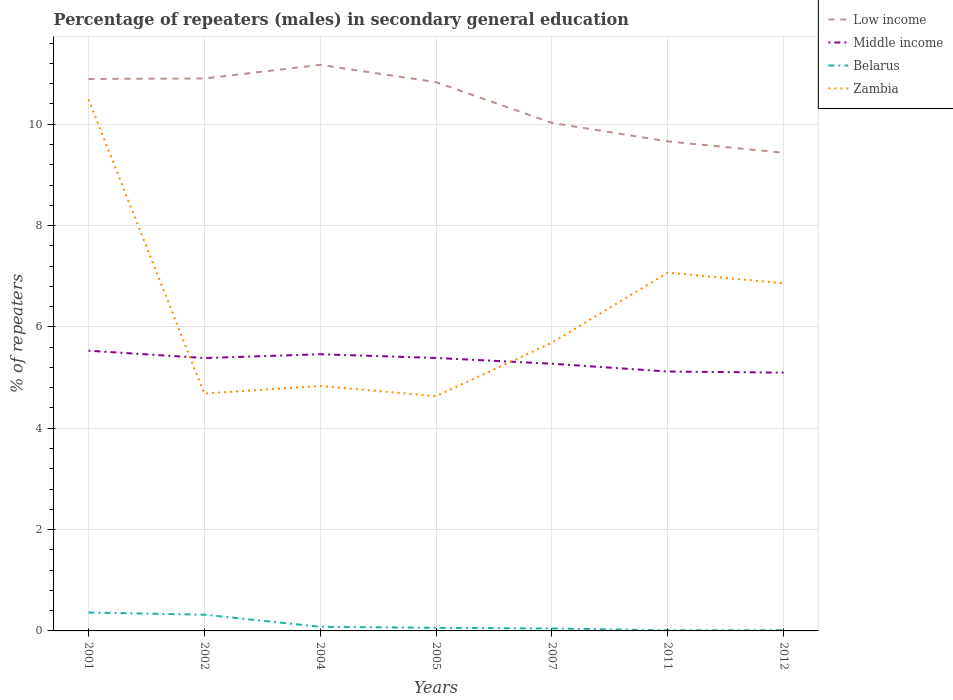How many different coloured lines are there?
Your answer should be very brief. 4. Across all years, what is the maximum percentage of male repeaters in Belarus?
Provide a succinct answer. 0.01. What is the total percentage of male repeaters in Belarus in the graph?
Your answer should be very brief. 0.28. What is the difference between the highest and the second highest percentage of male repeaters in Belarus?
Offer a very short reply. 0.35. What is the difference between the highest and the lowest percentage of male repeaters in Middle income?
Your response must be concise. 4. Is the percentage of male repeaters in Middle income strictly greater than the percentage of male repeaters in Zambia over the years?
Ensure brevity in your answer.  No. How many lines are there?
Ensure brevity in your answer.  4. How many years are there in the graph?
Your response must be concise. 7. What is the difference between two consecutive major ticks on the Y-axis?
Provide a short and direct response. 2. Are the values on the major ticks of Y-axis written in scientific E-notation?
Your response must be concise. No. Does the graph contain any zero values?
Your response must be concise. No. Does the graph contain grids?
Ensure brevity in your answer.  Yes. How are the legend labels stacked?
Provide a succinct answer. Vertical. What is the title of the graph?
Offer a very short reply. Percentage of repeaters (males) in secondary general education. What is the label or title of the Y-axis?
Your answer should be very brief. % of repeaters. What is the % of repeaters of Low income in 2001?
Provide a short and direct response. 10.89. What is the % of repeaters in Middle income in 2001?
Offer a terse response. 5.53. What is the % of repeaters of Belarus in 2001?
Provide a short and direct response. 0.36. What is the % of repeaters in Zambia in 2001?
Provide a succinct answer. 10.49. What is the % of repeaters of Low income in 2002?
Provide a short and direct response. 10.9. What is the % of repeaters of Middle income in 2002?
Provide a short and direct response. 5.39. What is the % of repeaters in Belarus in 2002?
Give a very brief answer. 0.32. What is the % of repeaters of Zambia in 2002?
Provide a succinct answer. 4.68. What is the % of repeaters of Low income in 2004?
Offer a very short reply. 11.17. What is the % of repeaters in Middle income in 2004?
Ensure brevity in your answer.  5.46. What is the % of repeaters of Belarus in 2004?
Give a very brief answer. 0.08. What is the % of repeaters in Zambia in 2004?
Provide a short and direct response. 4.83. What is the % of repeaters of Low income in 2005?
Your response must be concise. 10.83. What is the % of repeaters of Middle income in 2005?
Provide a succinct answer. 5.39. What is the % of repeaters of Belarus in 2005?
Offer a very short reply. 0.06. What is the % of repeaters in Zambia in 2005?
Your answer should be very brief. 4.63. What is the % of repeaters in Low income in 2007?
Give a very brief answer. 10.03. What is the % of repeaters in Middle income in 2007?
Give a very brief answer. 5.27. What is the % of repeaters of Belarus in 2007?
Give a very brief answer. 0.05. What is the % of repeaters of Zambia in 2007?
Your answer should be compact. 5.69. What is the % of repeaters of Low income in 2011?
Give a very brief answer. 9.66. What is the % of repeaters of Middle income in 2011?
Offer a terse response. 5.12. What is the % of repeaters in Belarus in 2011?
Keep it short and to the point. 0.01. What is the % of repeaters of Zambia in 2011?
Your answer should be compact. 7.07. What is the % of repeaters of Low income in 2012?
Provide a succinct answer. 9.44. What is the % of repeaters of Middle income in 2012?
Provide a succinct answer. 5.1. What is the % of repeaters in Belarus in 2012?
Provide a succinct answer. 0.01. What is the % of repeaters of Zambia in 2012?
Your answer should be compact. 6.86. Across all years, what is the maximum % of repeaters in Low income?
Your response must be concise. 11.17. Across all years, what is the maximum % of repeaters in Middle income?
Ensure brevity in your answer.  5.53. Across all years, what is the maximum % of repeaters in Belarus?
Offer a very short reply. 0.36. Across all years, what is the maximum % of repeaters of Zambia?
Make the answer very short. 10.49. Across all years, what is the minimum % of repeaters of Low income?
Provide a short and direct response. 9.44. Across all years, what is the minimum % of repeaters of Middle income?
Provide a succinct answer. 5.1. Across all years, what is the minimum % of repeaters in Belarus?
Keep it short and to the point. 0.01. Across all years, what is the minimum % of repeaters in Zambia?
Give a very brief answer. 4.63. What is the total % of repeaters in Low income in the graph?
Offer a terse response. 72.92. What is the total % of repeaters in Middle income in the graph?
Provide a succinct answer. 37.25. What is the total % of repeaters in Belarus in the graph?
Provide a succinct answer. 0.9. What is the total % of repeaters in Zambia in the graph?
Your answer should be very brief. 44.26. What is the difference between the % of repeaters in Low income in 2001 and that in 2002?
Your response must be concise. -0.01. What is the difference between the % of repeaters of Middle income in 2001 and that in 2002?
Keep it short and to the point. 0.15. What is the difference between the % of repeaters in Belarus in 2001 and that in 2002?
Ensure brevity in your answer.  0.04. What is the difference between the % of repeaters of Zambia in 2001 and that in 2002?
Your answer should be very brief. 5.81. What is the difference between the % of repeaters of Low income in 2001 and that in 2004?
Make the answer very short. -0.28. What is the difference between the % of repeaters in Middle income in 2001 and that in 2004?
Provide a succinct answer. 0.07. What is the difference between the % of repeaters in Belarus in 2001 and that in 2004?
Provide a short and direct response. 0.28. What is the difference between the % of repeaters of Zambia in 2001 and that in 2004?
Give a very brief answer. 5.66. What is the difference between the % of repeaters of Low income in 2001 and that in 2005?
Your answer should be compact. 0.06. What is the difference between the % of repeaters of Middle income in 2001 and that in 2005?
Ensure brevity in your answer.  0.14. What is the difference between the % of repeaters of Belarus in 2001 and that in 2005?
Keep it short and to the point. 0.3. What is the difference between the % of repeaters in Zambia in 2001 and that in 2005?
Make the answer very short. 5.86. What is the difference between the % of repeaters of Low income in 2001 and that in 2007?
Your answer should be very brief. 0.87. What is the difference between the % of repeaters in Middle income in 2001 and that in 2007?
Your answer should be compact. 0.26. What is the difference between the % of repeaters of Belarus in 2001 and that in 2007?
Give a very brief answer. 0.31. What is the difference between the % of repeaters of Zambia in 2001 and that in 2007?
Your answer should be compact. 4.8. What is the difference between the % of repeaters in Low income in 2001 and that in 2011?
Your response must be concise. 1.23. What is the difference between the % of repeaters of Middle income in 2001 and that in 2011?
Offer a very short reply. 0.41. What is the difference between the % of repeaters of Belarus in 2001 and that in 2011?
Provide a succinct answer. 0.35. What is the difference between the % of repeaters in Zambia in 2001 and that in 2011?
Your answer should be compact. 3.42. What is the difference between the % of repeaters of Low income in 2001 and that in 2012?
Ensure brevity in your answer.  1.46. What is the difference between the % of repeaters of Middle income in 2001 and that in 2012?
Make the answer very short. 0.43. What is the difference between the % of repeaters of Belarus in 2001 and that in 2012?
Offer a very short reply. 0.35. What is the difference between the % of repeaters of Zambia in 2001 and that in 2012?
Offer a very short reply. 3.63. What is the difference between the % of repeaters in Low income in 2002 and that in 2004?
Provide a succinct answer. -0.27. What is the difference between the % of repeaters in Middle income in 2002 and that in 2004?
Make the answer very short. -0.07. What is the difference between the % of repeaters of Belarus in 2002 and that in 2004?
Make the answer very short. 0.24. What is the difference between the % of repeaters in Zambia in 2002 and that in 2004?
Your response must be concise. -0.15. What is the difference between the % of repeaters of Low income in 2002 and that in 2005?
Keep it short and to the point. 0.07. What is the difference between the % of repeaters of Middle income in 2002 and that in 2005?
Ensure brevity in your answer.  -0. What is the difference between the % of repeaters of Belarus in 2002 and that in 2005?
Keep it short and to the point. 0.26. What is the difference between the % of repeaters in Zambia in 2002 and that in 2005?
Offer a terse response. 0.05. What is the difference between the % of repeaters of Low income in 2002 and that in 2007?
Offer a very short reply. 0.88. What is the difference between the % of repeaters in Middle income in 2002 and that in 2007?
Ensure brevity in your answer.  0.11. What is the difference between the % of repeaters in Belarus in 2002 and that in 2007?
Give a very brief answer. 0.27. What is the difference between the % of repeaters of Zambia in 2002 and that in 2007?
Ensure brevity in your answer.  -1. What is the difference between the % of repeaters of Low income in 2002 and that in 2011?
Provide a succinct answer. 1.24. What is the difference between the % of repeaters in Middle income in 2002 and that in 2011?
Your answer should be compact. 0.27. What is the difference between the % of repeaters in Belarus in 2002 and that in 2011?
Offer a terse response. 0.31. What is the difference between the % of repeaters of Zambia in 2002 and that in 2011?
Your response must be concise. -2.39. What is the difference between the % of repeaters in Low income in 2002 and that in 2012?
Ensure brevity in your answer.  1.47. What is the difference between the % of repeaters of Middle income in 2002 and that in 2012?
Keep it short and to the point. 0.29. What is the difference between the % of repeaters of Belarus in 2002 and that in 2012?
Keep it short and to the point. 0.31. What is the difference between the % of repeaters of Zambia in 2002 and that in 2012?
Your answer should be very brief. -2.18. What is the difference between the % of repeaters of Low income in 2004 and that in 2005?
Offer a very short reply. 0.34. What is the difference between the % of repeaters of Middle income in 2004 and that in 2005?
Provide a short and direct response. 0.07. What is the difference between the % of repeaters of Belarus in 2004 and that in 2005?
Keep it short and to the point. 0.02. What is the difference between the % of repeaters in Zambia in 2004 and that in 2005?
Offer a very short reply. 0.2. What is the difference between the % of repeaters of Low income in 2004 and that in 2007?
Keep it short and to the point. 1.15. What is the difference between the % of repeaters of Middle income in 2004 and that in 2007?
Your answer should be compact. 0.19. What is the difference between the % of repeaters in Belarus in 2004 and that in 2007?
Ensure brevity in your answer.  0.03. What is the difference between the % of repeaters in Zambia in 2004 and that in 2007?
Your answer should be very brief. -0.85. What is the difference between the % of repeaters in Low income in 2004 and that in 2011?
Your response must be concise. 1.51. What is the difference between the % of repeaters of Middle income in 2004 and that in 2011?
Offer a very short reply. 0.34. What is the difference between the % of repeaters of Belarus in 2004 and that in 2011?
Make the answer very short. 0.07. What is the difference between the % of repeaters in Zambia in 2004 and that in 2011?
Your response must be concise. -2.24. What is the difference between the % of repeaters of Low income in 2004 and that in 2012?
Offer a terse response. 1.74. What is the difference between the % of repeaters in Middle income in 2004 and that in 2012?
Provide a succinct answer. 0.36. What is the difference between the % of repeaters of Belarus in 2004 and that in 2012?
Keep it short and to the point. 0.07. What is the difference between the % of repeaters of Zambia in 2004 and that in 2012?
Your answer should be very brief. -2.03. What is the difference between the % of repeaters in Low income in 2005 and that in 2007?
Your answer should be very brief. 0.8. What is the difference between the % of repeaters in Middle income in 2005 and that in 2007?
Keep it short and to the point. 0.11. What is the difference between the % of repeaters in Belarus in 2005 and that in 2007?
Keep it short and to the point. 0.01. What is the difference between the % of repeaters of Zambia in 2005 and that in 2007?
Offer a terse response. -1.06. What is the difference between the % of repeaters of Low income in 2005 and that in 2011?
Ensure brevity in your answer.  1.17. What is the difference between the % of repeaters of Middle income in 2005 and that in 2011?
Provide a succinct answer. 0.27. What is the difference between the % of repeaters of Belarus in 2005 and that in 2011?
Keep it short and to the point. 0.05. What is the difference between the % of repeaters of Zambia in 2005 and that in 2011?
Your answer should be compact. -2.44. What is the difference between the % of repeaters of Low income in 2005 and that in 2012?
Your response must be concise. 1.39. What is the difference between the % of repeaters of Middle income in 2005 and that in 2012?
Provide a succinct answer. 0.29. What is the difference between the % of repeaters in Belarus in 2005 and that in 2012?
Your answer should be compact. 0.05. What is the difference between the % of repeaters of Zambia in 2005 and that in 2012?
Keep it short and to the point. -2.23. What is the difference between the % of repeaters of Low income in 2007 and that in 2011?
Provide a short and direct response. 0.36. What is the difference between the % of repeaters in Middle income in 2007 and that in 2011?
Make the answer very short. 0.15. What is the difference between the % of repeaters of Belarus in 2007 and that in 2011?
Give a very brief answer. 0.04. What is the difference between the % of repeaters in Zambia in 2007 and that in 2011?
Provide a succinct answer. -1.38. What is the difference between the % of repeaters of Low income in 2007 and that in 2012?
Your response must be concise. 0.59. What is the difference between the % of repeaters of Middle income in 2007 and that in 2012?
Make the answer very short. 0.18. What is the difference between the % of repeaters in Belarus in 2007 and that in 2012?
Keep it short and to the point. 0.04. What is the difference between the % of repeaters of Zambia in 2007 and that in 2012?
Make the answer very short. -1.17. What is the difference between the % of repeaters of Low income in 2011 and that in 2012?
Your response must be concise. 0.22. What is the difference between the % of repeaters of Middle income in 2011 and that in 2012?
Provide a succinct answer. 0.02. What is the difference between the % of repeaters in Belarus in 2011 and that in 2012?
Offer a terse response. -0. What is the difference between the % of repeaters in Zambia in 2011 and that in 2012?
Provide a succinct answer. 0.21. What is the difference between the % of repeaters of Low income in 2001 and the % of repeaters of Middle income in 2002?
Make the answer very short. 5.51. What is the difference between the % of repeaters in Low income in 2001 and the % of repeaters in Belarus in 2002?
Your response must be concise. 10.57. What is the difference between the % of repeaters of Low income in 2001 and the % of repeaters of Zambia in 2002?
Keep it short and to the point. 6.21. What is the difference between the % of repeaters of Middle income in 2001 and the % of repeaters of Belarus in 2002?
Your answer should be very brief. 5.21. What is the difference between the % of repeaters in Middle income in 2001 and the % of repeaters in Zambia in 2002?
Make the answer very short. 0.85. What is the difference between the % of repeaters in Belarus in 2001 and the % of repeaters in Zambia in 2002?
Your answer should be compact. -4.32. What is the difference between the % of repeaters in Low income in 2001 and the % of repeaters in Middle income in 2004?
Your response must be concise. 5.43. What is the difference between the % of repeaters of Low income in 2001 and the % of repeaters of Belarus in 2004?
Ensure brevity in your answer.  10.81. What is the difference between the % of repeaters of Low income in 2001 and the % of repeaters of Zambia in 2004?
Keep it short and to the point. 6.06. What is the difference between the % of repeaters of Middle income in 2001 and the % of repeaters of Belarus in 2004?
Offer a terse response. 5.45. What is the difference between the % of repeaters in Middle income in 2001 and the % of repeaters in Zambia in 2004?
Your answer should be compact. 0.7. What is the difference between the % of repeaters in Belarus in 2001 and the % of repeaters in Zambia in 2004?
Your answer should be compact. -4.47. What is the difference between the % of repeaters of Low income in 2001 and the % of repeaters of Middle income in 2005?
Give a very brief answer. 5.51. What is the difference between the % of repeaters of Low income in 2001 and the % of repeaters of Belarus in 2005?
Ensure brevity in your answer.  10.83. What is the difference between the % of repeaters in Low income in 2001 and the % of repeaters in Zambia in 2005?
Offer a terse response. 6.26. What is the difference between the % of repeaters in Middle income in 2001 and the % of repeaters in Belarus in 2005?
Offer a very short reply. 5.47. What is the difference between the % of repeaters of Middle income in 2001 and the % of repeaters of Zambia in 2005?
Your response must be concise. 0.9. What is the difference between the % of repeaters in Belarus in 2001 and the % of repeaters in Zambia in 2005?
Ensure brevity in your answer.  -4.27. What is the difference between the % of repeaters in Low income in 2001 and the % of repeaters in Middle income in 2007?
Your response must be concise. 5.62. What is the difference between the % of repeaters of Low income in 2001 and the % of repeaters of Belarus in 2007?
Offer a terse response. 10.84. What is the difference between the % of repeaters of Low income in 2001 and the % of repeaters of Zambia in 2007?
Your answer should be compact. 5.2. What is the difference between the % of repeaters of Middle income in 2001 and the % of repeaters of Belarus in 2007?
Keep it short and to the point. 5.48. What is the difference between the % of repeaters in Middle income in 2001 and the % of repeaters in Zambia in 2007?
Make the answer very short. -0.16. What is the difference between the % of repeaters of Belarus in 2001 and the % of repeaters of Zambia in 2007?
Provide a short and direct response. -5.33. What is the difference between the % of repeaters of Low income in 2001 and the % of repeaters of Middle income in 2011?
Offer a terse response. 5.77. What is the difference between the % of repeaters of Low income in 2001 and the % of repeaters of Belarus in 2011?
Your answer should be very brief. 10.88. What is the difference between the % of repeaters of Low income in 2001 and the % of repeaters of Zambia in 2011?
Offer a very short reply. 3.82. What is the difference between the % of repeaters of Middle income in 2001 and the % of repeaters of Belarus in 2011?
Offer a very short reply. 5.52. What is the difference between the % of repeaters in Middle income in 2001 and the % of repeaters in Zambia in 2011?
Provide a succinct answer. -1.54. What is the difference between the % of repeaters of Belarus in 2001 and the % of repeaters of Zambia in 2011?
Make the answer very short. -6.71. What is the difference between the % of repeaters of Low income in 2001 and the % of repeaters of Middle income in 2012?
Provide a short and direct response. 5.8. What is the difference between the % of repeaters in Low income in 2001 and the % of repeaters in Belarus in 2012?
Keep it short and to the point. 10.88. What is the difference between the % of repeaters of Low income in 2001 and the % of repeaters of Zambia in 2012?
Keep it short and to the point. 4.03. What is the difference between the % of repeaters in Middle income in 2001 and the % of repeaters in Belarus in 2012?
Provide a short and direct response. 5.52. What is the difference between the % of repeaters in Middle income in 2001 and the % of repeaters in Zambia in 2012?
Keep it short and to the point. -1.33. What is the difference between the % of repeaters in Belarus in 2001 and the % of repeaters in Zambia in 2012?
Provide a succinct answer. -6.5. What is the difference between the % of repeaters of Low income in 2002 and the % of repeaters of Middle income in 2004?
Make the answer very short. 5.44. What is the difference between the % of repeaters of Low income in 2002 and the % of repeaters of Belarus in 2004?
Keep it short and to the point. 10.82. What is the difference between the % of repeaters in Low income in 2002 and the % of repeaters in Zambia in 2004?
Ensure brevity in your answer.  6.07. What is the difference between the % of repeaters of Middle income in 2002 and the % of repeaters of Belarus in 2004?
Provide a short and direct response. 5.3. What is the difference between the % of repeaters of Middle income in 2002 and the % of repeaters of Zambia in 2004?
Your response must be concise. 0.55. What is the difference between the % of repeaters in Belarus in 2002 and the % of repeaters in Zambia in 2004?
Your answer should be compact. -4.51. What is the difference between the % of repeaters in Low income in 2002 and the % of repeaters in Middle income in 2005?
Provide a succinct answer. 5.52. What is the difference between the % of repeaters of Low income in 2002 and the % of repeaters of Belarus in 2005?
Your answer should be very brief. 10.84. What is the difference between the % of repeaters in Low income in 2002 and the % of repeaters in Zambia in 2005?
Your response must be concise. 6.27. What is the difference between the % of repeaters in Middle income in 2002 and the % of repeaters in Belarus in 2005?
Give a very brief answer. 5.32. What is the difference between the % of repeaters in Middle income in 2002 and the % of repeaters in Zambia in 2005?
Give a very brief answer. 0.75. What is the difference between the % of repeaters of Belarus in 2002 and the % of repeaters of Zambia in 2005?
Offer a very short reply. -4.31. What is the difference between the % of repeaters in Low income in 2002 and the % of repeaters in Middle income in 2007?
Your answer should be very brief. 5.63. What is the difference between the % of repeaters in Low income in 2002 and the % of repeaters in Belarus in 2007?
Keep it short and to the point. 10.85. What is the difference between the % of repeaters in Low income in 2002 and the % of repeaters in Zambia in 2007?
Offer a very short reply. 5.21. What is the difference between the % of repeaters of Middle income in 2002 and the % of repeaters of Belarus in 2007?
Your answer should be compact. 5.34. What is the difference between the % of repeaters of Middle income in 2002 and the % of repeaters of Zambia in 2007?
Offer a terse response. -0.3. What is the difference between the % of repeaters in Belarus in 2002 and the % of repeaters in Zambia in 2007?
Provide a succinct answer. -5.37. What is the difference between the % of repeaters in Low income in 2002 and the % of repeaters in Middle income in 2011?
Keep it short and to the point. 5.78. What is the difference between the % of repeaters in Low income in 2002 and the % of repeaters in Belarus in 2011?
Make the answer very short. 10.89. What is the difference between the % of repeaters of Low income in 2002 and the % of repeaters of Zambia in 2011?
Provide a short and direct response. 3.83. What is the difference between the % of repeaters in Middle income in 2002 and the % of repeaters in Belarus in 2011?
Your answer should be very brief. 5.37. What is the difference between the % of repeaters in Middle income in 2002 and the % of repeaters in Zambia in 2011?
Give a very brief answer. -1.69. What is the difference between the % of repeaters in Belarus in 2002 and the % of repeaters in Zambia in 2011?
Provide a short and direct response. -6.75. What is the difference between the % of repeaters of Low income in 2002 and the % of repeaters of Middle income in 2012?
Make the answer very short. 5.81. What is the difference between the % of repeaters in Low income in 2002 and the % of repeaters in Belarus in 2012?
Provide a succinct answer. 10.89. What is the difference between the % of repeaters in Low income in 2002 and the % of repeaters in Zambia in 2012?
Offer a very short reply. 4.04. What is the difference between the % of repeaters of Middle income in 2002 and the % of repeaters of Belarus in 2012?
Make the answer very short. 5.37. What is the difference between the % of repeaters in Middle income in 2002 and the % of repeaters in Zambia in 2012?
Provide a succinct answer. -1.48. What is the difference between the % of repeaters in Belarus in 2002 and the % of repeaters in Zambia in 2012?
Make the answer very short. -6.54. What is the difference between the % of repeaters in Low income in 2004 and the % of repeaters in Middle income in 2005?
Your response must be concise. 5.78. What is the difference between the % of repeaters in Low income in 2004 and the % of repeaters in Belarus in 2005?
Provide a succinct answer. 11.11. What is the difference between the % of repeaters in Low income in 2004 and the % of repeaters in Zambia in 2005?
Your response must be concise. 6.54. What is the difference between the % of repeaters of Middle income in 2004 and the % of repeaters of Belarus in 2005?
Your response must be concise. 5.4. What is the difference between the % of repeaters in Middle income in 2004 and the % of repeaters in Zambia in 2005?
Your answer should be very brief. 0.83. What is the difference between the % of repeaters of Belarus in 2004 and the % of repeaters of Zambia in 2005?
Ensure brevity in your answer.  -4.55. What is the difference between the % of repeaters of Low income in 2004 and the % of repeaters of Middle income in 2007?
Give a very brief answer. 5.9. What is the difference between the % of repeaters of Low income in 2004 and the % of repeaters of Belarus in 2007?
Provide a short and direct response. 11.12. What is the difference between the % of repeaters of Low income in 2004 and the % of repeaters of Zambia in 2007?
Keep it short and to the point. 5.48. What is the difference between the % of repeaters of Middle income in 2004 and the % of repeaters of Belarus in 2007?
Make the answer very short. 5.41. What is the difference between the % of repeaters in Middle income in 2004 and the % of repeaters in Zambia in 2007?
Your answer should be very brief. -0.23. What is the difference between the % of repeaters of Belarus in 2004 and the % of repeaters of Zambia in 2007?
Make the answer very short. -5.61. What is the difference between the % of repeaters in Low income in 2004 and the % of repeaters in Middle income in 2011?
Make the answer very short. 6.05. What is the difference between the % of repeaters in Low income in 2004 and the % of repeaters in Belarus in 2011?
Offer a terse response. 11.16. What is the difference between the % of repeaters of Low income in 2004 and the % of repeaters of Zambia in 2011?
Keep it short and to the point. 4.1. What is the difference between the % of repeaters of Middle income in 2004 and the % of repeaters of Belarus in 2011?
Your response must be concise. 5.45. What is the difference between the % of repeaters of Middle income in 2004 and the % of repeaters of Zambia in 2011?
Offer a terse response. -1.61. What is the difference between the % of repeaters of Belarus in 2004 and the % of repeaters of Zambia in 2011?
Make the answer very short. -6.99. What is the difference between the % of repeaters in Low income in 2004 and the % of repeaters in Middle income in 2012?
Your response must be concise. 6.07. What is the difference between the % of repeaters of Low income in 2004 and the % of repeaters of Belarus in 2012?
Your answer should be very brief. 11.16. What is the difference between the % of repeaters in Low income in 2004 and the % of repeaters in Zambia in 2012?
Your answer should be very brief. 4.31. What is the difference between the % of repeaters in Middle income in 2004 and the % of repeaters in Belarus in 2012?
Ensure brevity in your answer.  5.45. What is the difference between the % of repeaters of Middle income in 2004 and the % of repeaters of Zambia in 2012?
Ensure brevity in your answer.  -1.4. What is the difference between the % of repeaters of Belarus in 2004 and the % of repeaters of Zambia in 2012?
Offer a very short reply. -6.78. What is the difference between the % of repeaters of Low income in 2005 and the % of repeaters of Middle income in 2007?
Offer a very short reply. 5.56. What is the difference between the % of repeaters in Low income in 2005 and the % of repeaters in Belarus in 2007?
Provide a succinct answer. 10.78. What is the difference between the % of repeaters of Low income in 2005 and the % of repeaters of Zambia in 2007?
Your answer should be very brief. 5.14. What is the difference between the % of repeaters of Middle income in 2005 and the % of repeaters of Belarus in 2007?
Provide a succinct answer. 5.34. What is the difference between the % of repeaters of Middle income in 2005 and the % of repeaters of Zambia in 2007?
Offer a very short reply. -0.3. What is the difference between the % of repeaters of Belarus in 2005 and the % of repeaters of Zambia in 2007?
Ensure brevity in your answer.  -5.63. What is the difference between the % of repeaters of Low income in 2005 and the % of repeaters of Middle income in 2011?
Provide a succinct answer. 5.71. What is the difference between the % of repeaters in Low income in 2005 and the % of repeaters in Belarus in 2011?
Offer a very short reply. 10.82. What is the difference between the % of repeaters of Low income in 2005 and the % of repeaters of Zambia in 2011?
Your answer should be compact. 3.76. What is the difference between the % of repeaters in Middle income in 2005 and the % of repeaters in Belarus in 2011?
Ensure brevity in your answer.  5.38. What is the difference between the % of repeaters in Middle income in 2005 and the % of repeaters in Zambia in 2011?
Offer a terse response. -1.68. What is the difference between the % of repeaters in Belarus in 2005 and the % of repeaters in Zambia in 2011?
Provide a short and direct response. -7.01. What is the difference between the % of repeaters of Low income in 2005 and the % of repeaters of Middle income in 2012?
Your answer should be compact. 5.73. What is the difference between the % of repeaters in Low income in 2005 and the % of repeaters in Belarus in 2012?
Your response must be concise. 10.82. What is the difference between the % of repeaters of Low income in 2005 and the % of repeaters of Zambia in 2012?
Your answer should be compact. 3.97. What is the difference between the % of repeaters in Middle income in 2005 and the % of repeaters in Belarus in 2012?
Your response must be concise. 5.37. What is the difference between the % of repeaters in Middle income in 2005 and the % of repeaters in Zambia in 2012?
Make the answer very short. -1.47. What is the difference between the % of repeaters of Belarus in 2005 and the % of repeaters of Zambia in 2012?
Give a very brief answer. -6.8. What is the difference between the % of repeaters in Low income in 2007 and the % of repeaters in Middle income in 2011?
Your answer should be very brief. 4.91. What is the difference between the % of repeaters in Low income in 2007 and the % of repeaters in Belarus in 2011?
Make the answer very short. 10.01. What is the difference between the % of repeaters in Low income in 2007 and the % of repeaters in Zambia in 2011?
Ensure brevity in your answer.  2.95. What is the difference between the % of repeaters in Middle income in 2007 and the % of repeaters in Belarus in 2011?
Offer a terse response. 5.26. What is the difference between the % of repeaters of Middle income in 2007 and the % of repeaters of Zambia in 2011?
Your response must be concise. -1.8. What is the difference between the % of repeaters of Belarus in 2007 and the % of repeaters of Zambia in 2011?
Your answer should be very brief. -7.02. What is the difference between the % of repeaters of Low income in 2007 and the % of repeaters of Middle income in 2012?
Make the answer very short. 4.93. What is the difference between the % of repeaters of Low income in 2007 and the % of repeaters of Belarus in 2012?
Your answer should be very brief. 10.01. What is the difference between the % of repeaters in Low income in 2007 and the % of repeaters in Zambia in 2012?
Give a very brief answer. 3.16. What is the difference between the % of repeaters of Middle income in 2007 and the % of repeaters of Belarus in 2012?
Your answer should be compact. 5.26. What is the difference between the % of repeaters in Middle income in 2007 and the % of repeaters in Zambia in 2012?
Offer a terse response. -1.59. What is the difference between the % of repeaters of Belarus in 2007 and the % of repeaters of Zambia in 2012?
Offer a very short reply. -6.81. What is the difference between the % of repeaters in Low income in 2011 and the % of repeaters in Middle income in 2012?
Your answer should be very brief. 4.56. What is the difference between the % of repeaters of Low income in 2011 and the % of repeaters of Belarus in 2012?
Provide a short and direct response. 9.65. What is the difference between the % of repeaters of Middle income in 2011 and the % of repeaters of Belarus in 2012?
Your answer should be very brief. 5.11. What is the difference between the % of repeaters of Middle income in 2011 and the % of repeaters of Zambia in 2012?
Provide a short and direct response. -1.74. What is the difference between the % of repeaters in Belarus in 2011 and the % of repeaters in Zambia in 2012?
Provide a short and direct response. -6.85. What is the average % of repeaters in Low income per year?
Offer a very short reply. 10.42. What is the average % of repeaters in Middle income per year?
Provide a succinct answer. 5.32. What is the average % of repeaters of Belarus per year?
Your response must be concise. 0.13. What is the average % of repeaters of Zambia per year?
Make the answer very short. 6.32. In the year 2001, what is the difference between the % of repeaters of Low income and % of repeaters of Middle income?
Give a very brief answer. 5.36. In the year 2001, what is the difference between the % of repeaters of Low income and % of repeaters of Belarus?
Your answer should be compact. 10.53. In the year 2001, what is the difference between the % of repeaters of Low income and % of repeaters of Zambia?
Offer a very short reply. 0.4. In the year 2001, what is the difference between the % of repeaters of Middle income and % of repeaters of Belarus?
Your response must be concise. 5.17. In the year 2001, what is the difference between the % of repeaters in Middle income and % of repeaters in Zambia?
Offer a terse response. -4.96. In the year 2001, what is the difference between the % of repeaters in Belarus and % of repeaters in Zambia?
Offer a very short reply. -10.13. In the year 2002, what is the difference between the % of repeaters in Low income and % of repeaters in Middle income?
Keep it short and to the point. 5.52. In the year 2002, what is the difference between the % of repeaters of Low income and % of repeaters of Belarus?
Offer a very short reply. 10.58. In the year 2002, what is the difference between the % of repeaters of Low income and % of repeaters of Zambia?
Your response must be concise. 6.22. In the year 2002, what is the difference between the % of repeaters in Middle income and % of repeaters in Belarus?
Make the answer very short. 5.07. In the year 2002, what is the difference between the % of repeaters of Middle income and % of repeaters of Zambia?
Provide a short and direct response. 0.7. In the year 2002, what is the difference between the % of repeaters of Belarus and % of repeaters of Zambia?
Ensure brevity in your answer.  -4.36. In the year 2004, what is the difference between the % of repeaters of Low income and % of repeaters of Middle income?
Keep it short and to the point. 5.71. In the year 2004, what is the difference between the % of repeaters in Low income and % of repeaters in Belarus?
Ensure brevity in your answer.  11.09. In the year 2004, what is the difference between the % of repeaters of Low income and % of repeaters of Zambia?
Your answer should be compact. 6.34. In the year 2004, what is the difference between the % of repeaters in Middle income and % of repeaters in Belarus?
Provide a short and direct response. 5.38. In the year 2004, what is the difference between the % of repeaters in Middle income and % of repeaters in Zambia?
Offer a very short reply. 0.63. In the year 2004, what is the difference between the % of repeaters in Belarus and % of repeaters in Zambia?
Your answer should be very brief. -4.75. In the year 2005, what is the difference between the % of repeaters of Low income and % of repeaters of Middle income?
Provide a short and direct response. 5.44. In the year 2005, what is the difference between the % of repeaters in Low income and % of repeaters in Belarus?
Your response must be concise. 10.77. In the year 2005, what is the difference between the % of repeaters in Low income and % of repeaters in Zambia?
Ensure brevity in your answer.  6.2. In the year 2005, what is the difference between the % of repeaters of Middle income and % of repeaters of Belarus?
Keep it short and to the point. 5.33. In the year 2005, what is the difference between the % of repeaters in Middle income and % of repeaters in Zambia?
Offer a terse response. 0.75. In the year 2005, what is the difference between the % of repeaters in Belarus and % of repeaters in Zambia?
Offer a terse response. -4.57. In the year 2007, what is the difference between the % of repeaters of Low income and % of repeaters of Middle income?
Make the answer very short. 4.75. In the year 2007, what is the difference between the % of repeaters of Low income and % of repeaters of Belarus?
Offer a very short reply. 9.98. In the year 2007, what is the difference between the % of repeaters in Low income and % of repeaters in Zambia?
Provide a short and direct response. 4.34. In the year 2007, what is the difference between the % of repeaters in Middle income and % of repeaters in Belarus?
Ensure brevity in your answer.  5.22. In the year 2007, what is the difference between the % of repeaters of Middle income and % of repeaters of Zambia?
Provide a succinct answer. -0.42. In the year 2007, what is the difference between the % of repeaters in Belarus and % of repeaters in Zambia?
Keep it short and to the point. -5.64. In the year 2011, what is the difference between the % of repeaters of Low income and % of repeaters of Middle income?
Give a very brief answer. 4.54. In the year 2011, what is the difference between the % of repeaters of Low income and % of repeaters of Belarus?
Ensure brevity in your answer.  9.65. In the year 2011, what is the difference between the % of repeaters of Low income and % of repeaters of Zambia?
Ensure brevity in your answer.  2.59. In the year 2011, what is the difference between the % of repeaters of Middle income and % of repeaters of Belarus?
Ensure brevity in your answer.  5.11. In the year 2011, what is the difference between the % of repeaters in Middle income and % of repeaters in Zambia?
Your response must be concise. -1.95. In the year 2011, what is the difference between the % of repeaters of Belarus and % of repeaters of Zambia?
Offer a very short reply. -7.06. In the year 2012, what is the difference between the % of repeaters of Low income and % of repeaters of Middle income?
Provide a short and direct response. 4.34. In the year 2012, what is the difference between the % of repeaters of Low income and % of repeaters of Belarus?
Offer a very short reply. 9.42. In the year 2012, what is the difference between the % of repeaters in Low income and % of repeaters in Zambia?
Your answer should be very brief. 2.58. In the year 2012, what is the difference between the % of repeaters of Middle income and % of repeaters of Belarus?
Give a very brief answer. 5.08. In the year 2012, what is the difference between the % of repeaters in Middle income and % of repeaters in Zambia?
Give a very brief answer. -1.76. In the year 2012, what is the difference between the % of repeaters in Belarus and % of repeaters in Zambia?
Your answer should be compact. -6.85. What is the ratio of the % of repeaters of Middle income in 2001 to that in 2002?
Your answer should be compact. 1.03. What is the ratio of the % of repeaters in Belarus in 2001 to that in 2002?
Offer a very short reply. 1.13. What is the ratio of the % of repeaters in Zambia in 2001 to that in 2002?
Keep it short and to the point. 2.24. What is the ratio of the % of repeaters in Low income in 2001 to that in 2004?
Offer a terse response. 0.98. What is the ratio of the % of repeaters in Middle income in 2001 to that in 2004?
Your answer should be very brief. 1.01. What is the ratio of the % of repeaters in Belarus in 2001 to that in 2004?
Your answer should be compact. 4.45. What is the ratio of the % of repeaters of Zambia in 2001 to that in 2004?
Make the answer very short. 2.17. What is the ratio of the % of repeaters of Low income in 2001 to that in 2005?
Ensure brevity in your answer.  1.01. What is the ratio of the % of repeaters of Middle income in 2001 to that in 2005?
Provide a short and direct response. 1.03. What is the ratio of the % of repeaters in Belarus in 2001 to that in 2005?
Provide a short and direct response. 5.94. What is the ratio of the % of repeaters in Zambia in 2001 to that in 2005?
Your answer should be compact. 2.26. What is the ratio of the % of repeaters in Low income in 2001 to that in 2007?
Offer a terse response. 1.09. What is the ratio of the % of repeaters of Middle income in 2001 to that in 2007?
Provide a succinct answer. 1.05. What is the ratio of the % of repeaters in Belarus in 2001 to that in 2007?
Your response must be concise. 7.46. What is the ratio of the % of repeaters of Zambia in 2001 to that in 2007?
Offer a terse response. 1.84. What is the ratio of the % of repeaters in Low income in 2001 to that in 2011?
Provide a short and direct response. 1.13. What is the ratio of the % of repeaters of Middle income in 2001 to that in 2011?
Give a very brief answer. 1.08. What is the ratio of the % of repeaters in Belarus in 2001 to that in 2011?
Your answer should be compact. 30.88. What is the ratio of the % of repeaters in Zambia in 2001 to that in 2011?
Ensure brevity in your answer.  1.48. What is the ratio of the % of repeaters of Low income in 2001 to that in 2012?
Your answer should be compact. 1.15. What is the ratio of the % of repeaters of Middle income in 2001 to that in 2012?
Provide a succinct answer. 1.08. What is the ratio of the % of repeaters in Belarus in 2001 to that in 2012?
Offer a terse response. 28.19. What is the ratio of the % of repeaters of Zambia in 2001 to that in 2012?
Keep it short and to the point. 1.53. What is the ratio of the % of repeaters in Low income in 2002 to that in 2004?
Make the answer very short. 0.98. What is the ratio of the % of repeaters of Middle income in 2002 to that in 2004?
Offer a terse response. 0.99. What is the ratio of the % of repeaters of Belarus in 2002 to that in 2004?
Your answer should be very brief. 3.93. What is the ratio of the % of repeaters of Zambia in 2002 to that in 2004?
Provide a succinct answer. 0.97. What is the ratio of the % of repeaters in Belarus in 2002 to that in 2005?
Offer a terse response. 5.24. What is the ratio of the % of repeaters of Low income in 2002 to that in 2007?
Your answer should be compact. 1.09. What is the ratio of the % of repeaters in Middle income in 2002 to that in 2007?
Your response must be concise. 1.02. What is the ratio of the % of repeaters of Belarus in 2002 to that in 2007?
Give a very brief answer. 6.57. What is the ratio of the % of repeaters of Zambia in 2002 to that in 2007?
Offer a terse response. 0.82. What is the ratio of the % of repeaters of Low income in 2002 to that in 2011?
Give a very brief answer. 1.13. What is the ratio of the % of repeaters of Middle income in 2002 to that in 2011?
Your answer should be compact. 1.05. What is the ratio of the % of repeaters in Belarus in 2002 to that in 2011?
Ensure brevity in your answer.  27.22. What is the ratio of the % of repeaters of Zambia in 2002 to that in 2011?
Offer a very short reply. 0.66. What is the ratio of the % of repeaters of Low income in 2002 to that in 2012?
Keep it short and to the point. 1.16. What is the ratio of the % of repeaters of Middle income in 2002 to that in 2012?
Give a very brief answer. 1.06. What is the ratio of the % of repeaters of Belarus in 2002 to that in 2012?
Ensure brevity in your answer.  24.85. What is the ratio of the % of repeaters of Zambia in 2002 to that in 2012?
Provide a short and direct response. 0.68. What is the ratio of the % of repeaters of Low income in 2004 to that in 2005?
Offer a very short reply. 1.03. What is the ratio of the % of repeaters of Middle income in 2004 to that in 2005?
Provide a succinct answer. 1.01. What is the ratio of the % of repeaters in Belarus in 2004 to that in 2005?
Offer a very short reply. 1.33. What is the ratio of the % of repeaters in Zambia in 2004 to that in 2005?
Provide a succinct answer. 1.04. What is the ratio of the % of repeaters of Low income in 2004 to that in 2007?
Provide a short and direct response. 1.11. What is the ratio of the % of repeaters in Middle income in 2004 to that in 2007?
Ensure brevity in your answer.  1.04. What is the ratio of the % of repeaters in Belarus in 2004 to that in 2007?
Your response must be concise. 1.67. What is the ratio of the % of repeaters of Zambia in 2004 to that in 2007?
Ensure brevity in your answer.  0.85. What is the ratio of the % of repeaters of Low income in 2004 to that in 2011?
Provide a succinct answer. 1.16. What is the ratio of the % of repeaters in Middle income in 2004 to that in 2011?
Offer a very short reply. 1.07. What is the ratio of the % of repeaters in Belarus in 2004 to that in 2011?
Ensure brevity in your answer.  6.93. What is the ratio of the % of repeaters in Zambia in 2004 to that in 2011?
Offer a very short reply. 0.68. What is the ratio of the % of repeaters of Low income in 2004 to that in 2012?
Provide a short and direct response. 1.18. What is the ratio of the % of repeaters of Middle income in 2004 to that in 2012?
Offer a terse response. 1.07. What is the ratio of the % of repeaters in Belarus in 2004 to that in 2012?
Give a very brief answer. 6.33. What is the ratio of the % of repeaters in Zambia in 2004 to that in 2012?
Your answer should be compact. 0.7. What is the ratio of the % of repeaters of Low income in 2005 to that in 2007?
Offer a very short reply. 1.08. What is the ratio of the % of repeaters in Middle income in 2005 to that in 2007?
Ensure brevity in your answer.  1.02. What is the ratio of the % of repeaters in Belarus in 2005 to that in 2007?
Ensure brevity in your answer.  1.26. What is the ratio of the % of repeaters of Zambia in 2005 to that in 2007?
Offer a very short reply. 0.81. What is the ratio of the % of repeaters of Low income in 2005 to that in 2011?
Your answer should be compact. 1.12. What is the ratio of the % of repeaters of Middle income in 2005 to that in 2011?
Provide a succinct answer. 1.05. What is the ratio of the % of repeaters of Belarus in 2005 to that in 2011?
Keep it short and to the point. 5.2. What is the ratio of the % of repeaters of Zambia in 2005 to that in 2011?
Ensure brevity in your answer.  0.66. What is the ratio of the % of repeaters of Low income in 2005 to that in 2012?
Give a very brief answer. 1.15. What is the ratio of the % of repeaters of Middle income in 2005 to that in 2012?
Provide a short and direct response. 1.06. What is the ratio of the % of repeaters of Belarus in 2005 to that in 2012?
Offer a very short reply. 4.75. What is the ratio of the % of repeaters in Zambia in 2005 to that in 2012?
Your answer should be very brief. 0.68. What is the ratio of the % of repeaters of Low income in 2007 to that in 2011?
Your response must be concise. 1.04. What is the ratio of the % of repeaters of Middle income in 2007 to that in 2011?
Offer a very short reply. 1.03. What is the ratio of the % of repeaters of Belarus in 2007 to that in 2011?
Your answer should be very brief. 4.14. What is the ratio of the % of repeaters of Zambia in 2007 to that in 2011?
Provide a short and direct response. 0.8. What is the ratio of the % of repeaters of Low income in 2007 to that in 2012?
Make the answer very short. 1.06. What is the ratio of the % of repeaters in Middle income in 2007 to that in 2012?
Ensure brevity in your answer.  1.03. What is the ratio of the % of repeaters in Belarus in 2007 to that in 2012?
Give a very brief answer. 3.78. What is the ratio of the % of repeaters of Zambia in 2007 to that in 2012?
Make the answer very short. 0.83. What is the ratio of the % of repeaters of Low income in 2011 to that in 2012?
Give a very brief answer. 1.02. What is the ratio of the % of repeaters in Middle income in 2011 to that in 2012?
Offer a very short reply. 1. What is the ratio of the % of repeaters of Zambia in 2011 to that in 2012?
Make the answer very short. 1.03. What is the difference between the highest and the second highest % of repeaters of Low income?
Your answer should be very brief. 0.27. What is the difference between the highest and the second highest % of repeaters in Middle income?
Your answer should be very brief. 0.07. What is the difference between the highest and the second highest % of repeaters in Belarus?
Provide a succinct answer. 0.04. What is the difference between the highest and the second highest % of repeaters of Zambia?
Provide a succinct answer. 3.42. What is the difference between the highest and the lowest % of repeaters of Low income?
Your answer should be compact. 1.74. What is the difference between the highest and the lowest % of repeaters in Middle income?
Offer a terse response. 0.43. What is the difference between the highest and the lowest % of repeaters of Belarus?
Offer a terse response. 0.35. What is the difference between the highest and the lowest % of repeaters of Zambia?
Ensure brevity in your answer.  5.86. 